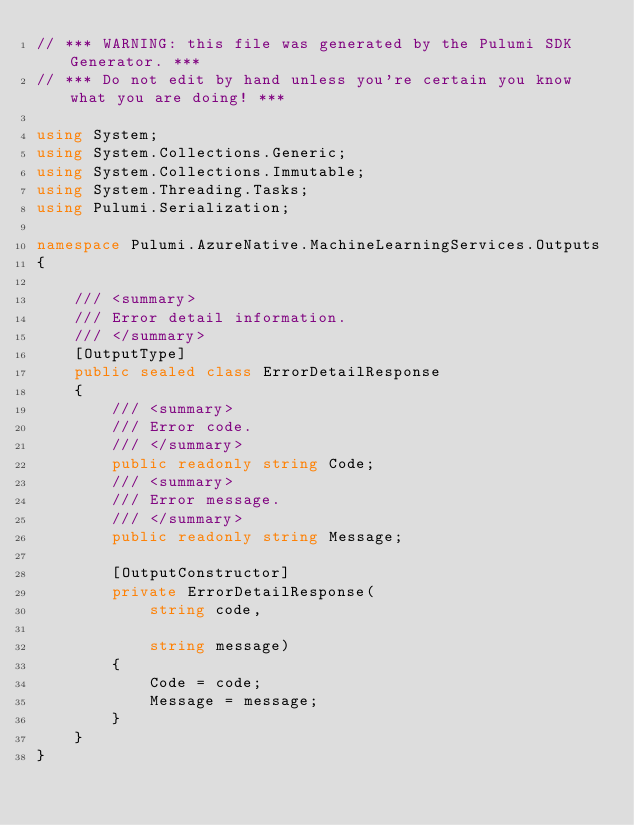<code> <loc_0><loc_0><loc_500><loc_500><_C#_>// *** WARNING: this file was generated by the Pulumi SDK Generator. ***
// *** Do not edit by hand unless you're certain you know what you are doing! ***

using System;
using System.Collections.Generic;
using System.Collections.Immutable;
using System.Threading.Tasks;
using Pulumi.Serialization;

namespace Pulumi.AzureNative.MachineLearningServices.Outputs
{

    /// <summary>
    /// Error detail information.
    /// </summary>
    [OutputType]
    public sealed class ErrorDetailResponse
    {
        /// <summary>
        /// Error code.
        /// </summary>
        public readonly string Code;
        /// <summary>
        /// Error message.
        /// </summary>
        public readonly string Message;

        [OutputConstructor]
        private ErrorDetailResponse(
            string code,

            string message)
        {
            Code = code;
            Message = message;
        }
    }
}
</code> 